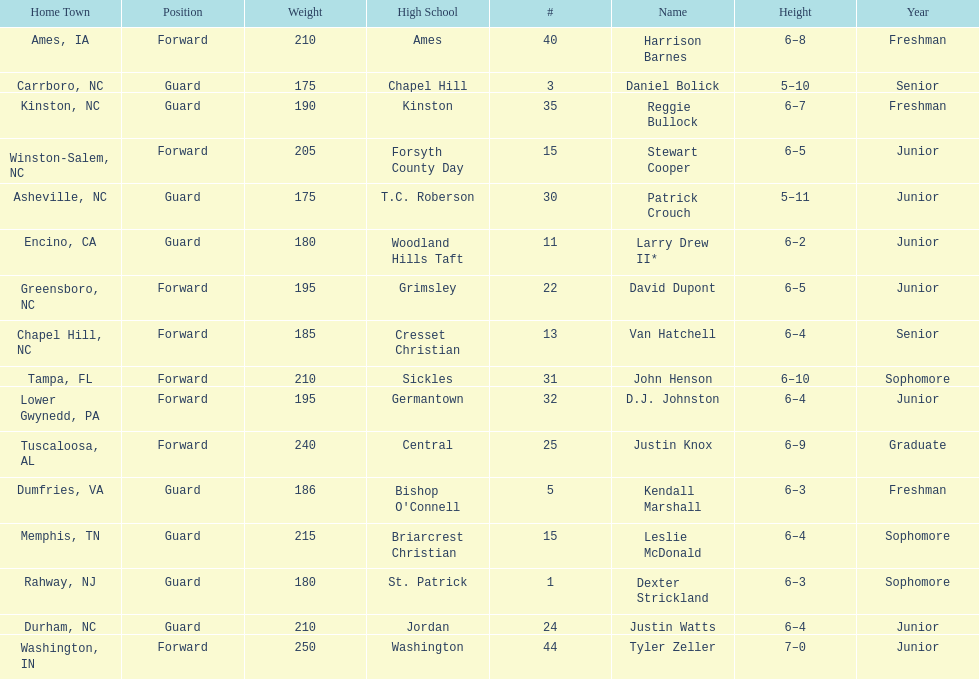How many players play a position other than guard? 8. 